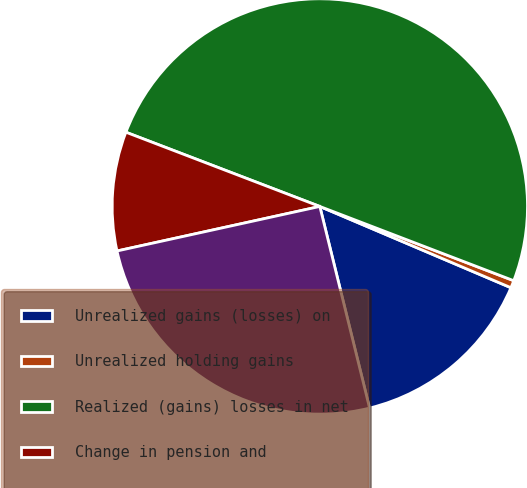Convert chart to OTSL. <chart><loc_0><loc_0><loc_500><loc_500><pie_chart><fcel>Unrealized gains (losses) on<fcel>Unrealized holding gains<fcel>Realized (gains) losses in net<fcel>Change in pension and<fcel>Other comprehensive income<nl><fcel>14.75%<fcel>0.58%<fcel>50.0%<fcel>9.26%<fcel>25.41%<nl></chart> 